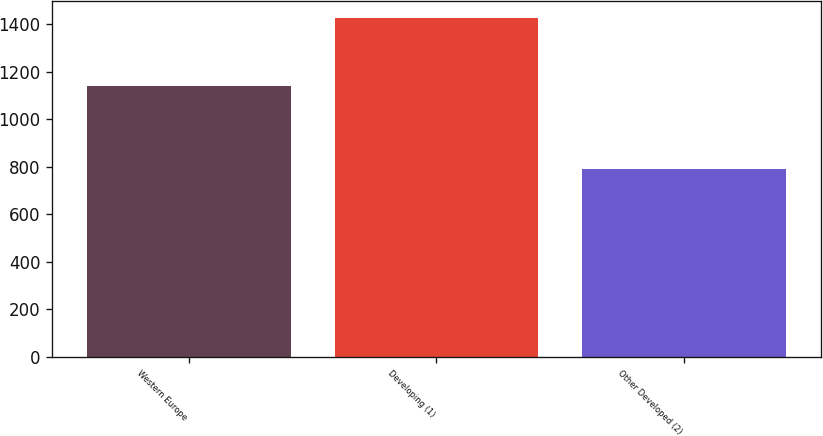Convert chart. <chart><loc_0><loc_0><loc_500><loc_500><bar_chart><fcel>Western Europe<fcel>Developing (1)<fcel>Other Developed (2)<nl><fcel>1141.5<fcel>1425.6<fcel>790.9<nl></chart> 